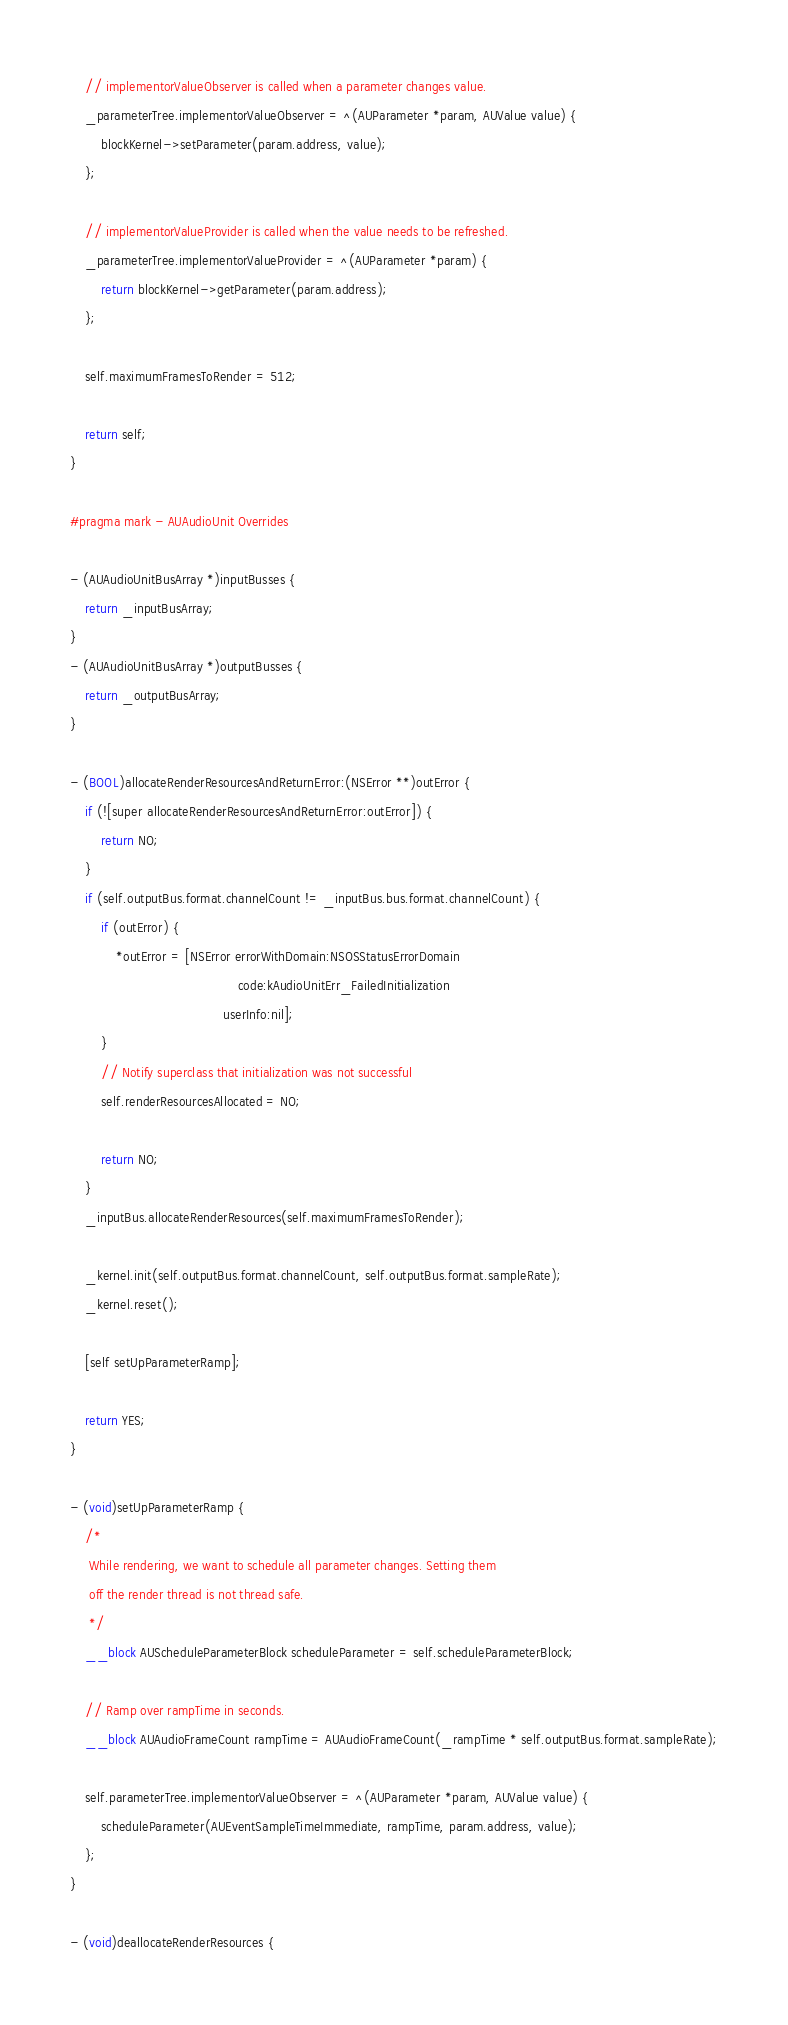<code> <loc_0><loc_0><loc_500><loc_500><_ObjectiveC_>    // implementorValueObserver is called when a parameter changes value.
    _parameterTree.implementorValueObserver = ^(AUParameter *param, AUValue value) {
        blockKernel->setParameter(param.address, value);
    };

    // implementorValueProvider is called when the value needs to be refreshed.
    _parameterTree.implementorValueProvider = ^(AUParameter *param) {
        return blockKernel->getParameter(param.address);
    };

    self.maximumFramesToRender = 512;

    return self;
}

#pragma mark - AUAudioUnit Overrides

- (AUAudioUnitBusArray *)inputBusses {
    return _inputBusArray;
}
- (AUAudioUnitBusArray *)outputBusses {
    return _outputBusArray;
}

- (BOOL)allocateRenderResourcesAndReturnError:(NSError **)outError {
    if (![super allocateRenderResourcesAndReturnError:outError]) {
        return NO;
    }
    if (self.outputBus.format.channelCount != _inputBus.bus.format.channelCount) {
        if (outError) {
            *outError = [NSError errorWithDomain:NSOSStatusErrorDomain
                                            code:kAudioUnitErr_FailedInitialization
                                        userInfo:nil];
        }
        // Notify superclass that initialization was not successful
        self.renderResourcesAllocated = NO;

        return NO;
    }
    _inputBus.allocateRenderResources(self.maximumFramesToRender);

    _kernel.init(self.outputBus.format.channelCount, self.outputBus.format.sampleRate);
    _kernel.reset();

    [self setUpParameterRamp];

    return YES;
}

- (void)setUpParameterRamp {
    /*
     While rendering, we want to schedule all parameter changes. Setting them
     off the render thread is not thread safe.
     */
    __block AUScheduleParameterBlock scheduleParameter = self.scheduleParameterBlock;

    // Ramp over rampTime in seconds.
    __block AUAudioFrameCount rampTime = AUAudioFrameCount(_rampTime * self.outputBus.format.sampleRate);

    self.parameterTree.implementorValueObserver = ^(AUParameter *param, AUValue value) {
        scheduleParameter(AUEventSampleTimeImmediate, rampTime, param.address, value);
    };
}

- (void)deallocateRenderResources {</code> 